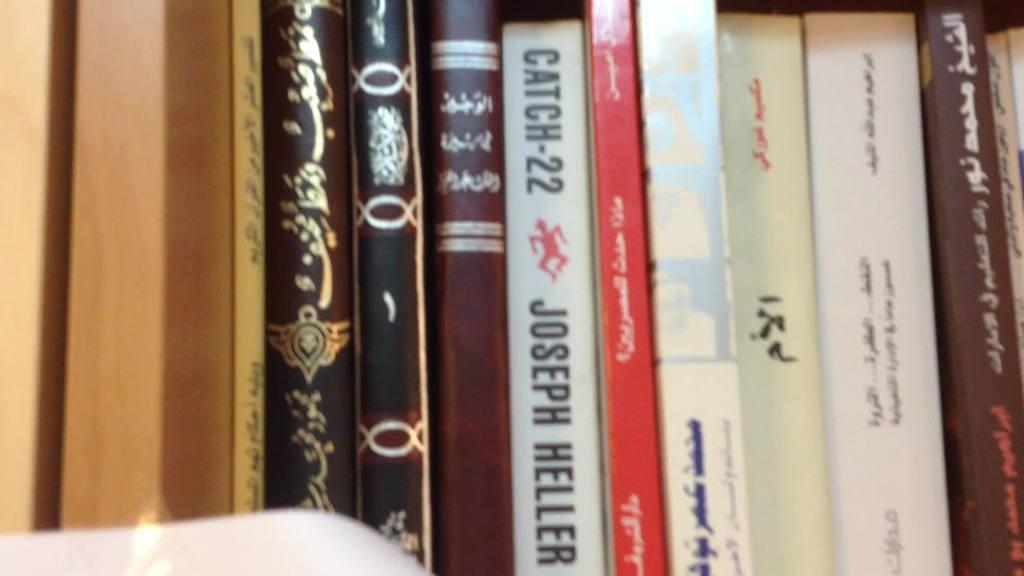<image>
Give a short and clear explanation of the subsequent image. A book titled, "Catch-22" sits on a shelf next to a red book. 